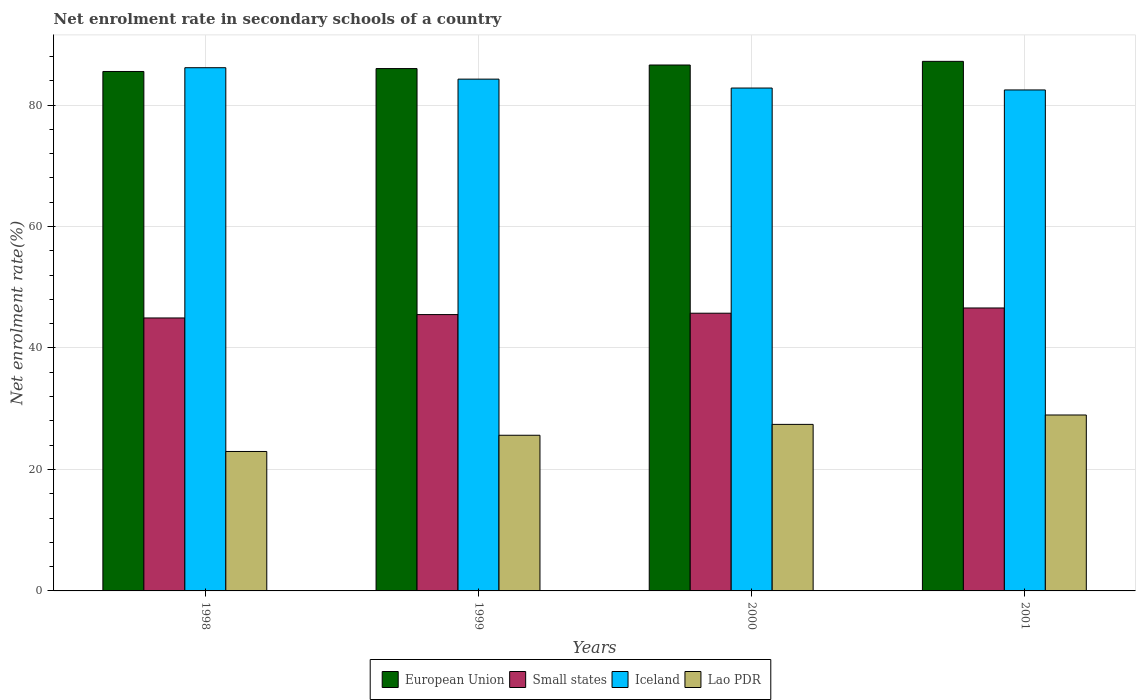How many groups of bars are there?
Provide a succinct answer. 4. Are the number of bars per tick equal to the number of legend labels?
Your answer should be compact. Yes. Are the number of bars on each tick of the X-axis equal?
Keep it short and to the point. Yes. How many bars are there on the 4th tick from the left?
Your answer should be compact. 4. How many bars are there on the 4th tick from the right?
Give a very brief answer. 4. What is the net enrolment rate in secondary schools in Small states in 1998?
Offer a terse response. 44.94. Across all years, what is the maximum net enrolment rate in secondary schools in Lao PDR?
Give a very brief answer. 28.97. Across all years, what is the minimum net enrolment rate in secondary schools in Small states?
Your answer should be very brief. 44.94. In which year was the net enrolment rate in secondary schools in European Union maximum?
Your response must be concise. 2001. In which year was the net enrolment rate in secondary schools in Iceland minimum?
Offer a very short reply. 2001. What is the total net enrolment rate in secondary schools in Lao PDR in the graph?
Make the answer very short. 104.98. What is the difference between the net enrolment rate in secondary schools in Iceland in 1999 and that in 2001?
Your answer should be compact. 1.78. What is the difference between the net enrolment rate in secondary schools in Iceland in 2000 and the net enrolment rate in secondary schools in Small states in 1998?
Your answer should be very brief. 37.86. What is the average net enrolment rate in secondary schools in European Union per year?
Offer a terse response. 86.33. In the year 2001, what is the difference between the net enrolment rate in secondary schools in Iceland and net enrolment rate in secondary schools in Small states?
Keep it short and to the point. 35.9. What is the ratio of the net enrolment rate in secondary schools in European Union in 1998 to that in 2001?
Your answer should be compact. 0.98. Is the net enrolment rate in secondary schools in Small states in 2000 less than that in 2001?
Offer a terse response. Yes. What is the difference between the highest and the second highest net enrolment rate in secondary schools in European Union?
Ensure brevity in your answer.  0.6. What is the difference between the highest and the lowest net enrolment rate in secondary schools in Lao PDR?
Give a very brief answer. 6.01. In how many years, is the net enrolment rate in secondary schools in European Union greater than the average net enrolment rate in secondary schools in European Union taken over all years?
Provide a succinct answer. 2. Is the sum of the net enrolment rate in secondary schools in European Union in 1998 and 2000 greater than the maximum net enrolment rate in secondary schools in Lao PDR across all years?
Your answer should be compact. Yes. Is it the case that in every year, the sum of the net enrolment rate in secondary schools in European Union and net enrolment rate in secondary schools in Lao PDR is greater than the sum of net enrolment rate in secondary schools in Small states and net enrolment rate in secondary schools in Iceland?
Your answer should be compact. Yes. What does the 4th bar from the left in 2000 represents?
Your response must be concise. Lao PDR. What does the 3rd bar from the right in 1999 represents?
Provide a succinct answer. Small states. Is it the case that in every year, the sum of the net enrolment rate in secondary schools in Lao PDR and net enrolment rate in secondary schools in Iceland is greater than the net enrolment rate in secondary schools in Small states?
Offer a terse response. Yes. How many bars are there?
Provide a succinct answer. 16. Are all the bars in the graph horizontal?
Offer a terse response. No. How many years are there in the graph?
Your response must be concise. 4. Does the graph contain grids?
Offer a very short reply. Yes. Where does the legend appear in the graph?
Ensure brevity in your answer.  Bottom center. How many legend labels are there?
Ensure brevity in your answer.  4. How are the legend labels stacked?
Provide a succinct answer. Horizontal. What is the title of the graph?
Provide a succinct answer. Net enrolment rate in secondary schools of a country. What is the label or title of the X-axis?
Offer a very short reply. Years. What is the label or title of the Y-axis?
Make the answer very short. Net enrolment rate(%). What is the Net enrolment rate(%) of European Union in 1998?
Keep it short and to the point. 85.53. What is the Net enrolment rate(%) in Small states in 1998?
Your answer should be very brief. 44.94. What is the Net enrolment rate(%) of Iceland in 1998?
Make the answer very short. 86.15. What is the Net enrolment rate(%) in Lao PDR in 1998?
Your answer should be very brief. 22.96. What is the Net enrolment rate(%) of European Union in 1999?
Keep it short and to the point. 86.01. What is the Net enrolment rate(%) in Small states in 1999?
Keep it short and to the point. 45.5. What is the Net enrolment rate(%) in Iceland in 1999?
Keep it short and to the point. 84.27. What is the Net enrolment rate(%) in Lao PDR in 1999?
Offer a very short reply. 25.63. What is the Net enrolment rate(%) in European Union in 2000?
Offer a very short reply. 86.59. What is the Net enrolment rate(%) in Small states in 2000?
Provide a short and direct response. 45.72. What is the Net enrolment rate(%) of Iceland in 2000?
Ensure brevity in your answer.  82.8. What is the Net enrolment rate(%) in Lao PDR in 2000?
Give a very brief answer. 27.42. What is the Net enrolment rate(%) in European Union in 2001?
Give a very brief answer. 87.19. What is the Net enrolment rate(%) of Small states in 2001?
Provide a short and direct response. 46.59. What is the Net enrolment rate(%) of Iceland in 2001?
Make the answer very short. 82.49. What is the Net enrolment rate(%) in Lao PDR in 2001?
Make the answer very short. 28.97. Across all years, what is the maximum Net enrolment rate(%) of European Union?
Your answer should be compact. 87.19. Across all years, what is the maximum Net enrolment rate(%) of Small states?
Provide a short and direct response. 46.59. Across all years, what is the maximum Net enrolment rate(%) of Iceland?
Make the answer very short. 86.15. Across all years, what is the maximum Net enrolment rate(%) in Lao PDR?
Your response must be concise. 28.97. Across all years, what is the minimum Net enrolment rate(%) of European Union?
Your response must be concise. 85.53. Across all years, what is the minimum Net enrolment rate(%) of Small states?
Ensure brevity in your answer.  44.94. Across all years, what is the minimum Net enrolment rate(%) in Iceland?
Keep it short and to the point. 82.49. Across all years, what is the minimum Net enrolment rate(%) in Lao PDR?
Give a very brief answer. 22.96. What is the total Net enrolment rate(%) in European Union in the graph?
Provide a succinct answer. 345.32. What is the total Net enrolment rate(%) in Small states in the graph?
Ensure brevity in your answer.  182.75. What is the total Net enrolment rate(%) of Iceland in the graph?
Offer a terse response. 335.7. What is the total Net enrolment rate(%) of Lao PDR in the graph?
Your answer should be very brief. 104.98. What is the difference between the Net enrolment rate(%) in European Union in 1998 and that in 1999?
Provide a succinct answer. -0.48. What is the difference between the Net enrolment rate(%) of Small states in 1998 and that in 1999?
Your response must be concise. -0.56. What is the difference between the Net enrolment rate(%) of Iceland in 1998 and that in 1999?
Your answer should be compact. 1.88. What is the difference between the Net enrolment rate(%) in Lao PDR in 1998 and that in 1999?
Provide a succinct answer. -2.67. What is the difference between the Net enrolment rate(%) of European Union in 1998 and that in 2000?
Your answer should be compact. -1.07. What is the difference between the Net enrolment rate(%) in Small states in 1998 and that in 2000?
Make the answer very short. -0.78. What is the difference between the Net enrolment rate(%) in Iceland in 1998 and that in 2000?
Provide a short and direct response. 3.35. What is the difference between the Net enrolment rate(%) in Lao PDR in 1998 and that in 2000?
Ensure brevity in your answer.  -4.46. What is the difference between the Net enrolment rate(%) in European Union in 1998 and that in 2001?
Make the answer very short. -1.67. What is the difference between the Net enrolment rate(%) of Small states in 1998 and that in 2001?
Your answer should be very brief. -1.64. What is the difference between the Net enrolment rate(%) in Iceland in 1998 and that in 2001?
Ensure brevity in your answer.  3.66. What is the difference between the Net enrolment rate(%) of Lao PDR in 1998 and that in 2001?
Give a very brief answer. -6.01. What is the difference between the Net enrolment rate(%) in European Union in 1999 and that in 2000?
Your answer should be very brief. -0.59. What is the difference between the Net enrolment rate(%) of Small states in 1999 and that in 2000?
Your answer should be compact. -0.22. What is the difference between the Net enrolment rate(%) of Iceland in 1999 and that in 2000?
Make the answer very short. 1.47. What is the difference between the Net enrolment rate(%) in Lao PDR in 1999 and that in 2000?
Offer a terse response. -1.79. What is the difference between the Net enrolment rate(%) of European Union in 1999 and that in 2001?
Offer a terse response. -1.19. What is the difference between the Net enrolment rate(%) in Small states in 1999 and that in 2001?
Provide a succinct answer. -1.09. What is the difference between the Net enrolment rate(%) of Iceland in 1999 and that in 2001?
Ensure brevity in your answer.  1.78. What is the difference between the Net enrolment rate(%) of Lao PDR in 1999 and that in 2001?
Make the answer very short. -3.34. What is the difference between the Net enrolment rate(%) in European Union in 2000 and that in 2001?
Make the answer very short. -0.6. What is the difference between the Net enrolment rate(%) in Small states in 2000 and that in 2001?
Your answer should be compact. -0.86. What is the difference between the Net enrolment rate(%) of Iceland in 2000 and that in 2001?
Your answer should be very brief. 0.31. What is the difference between the Net enrolment rate(%) of Lao PDR in 2000 and that in 2001?
Provide a short and direct response. -1.55. What is the difference between the Net enrolment rate(%) of European Union in 1998 and the Net enrolment rate(%) of Small states in 1999?
Keep it short and to the point. 40.03. What is the difference between the Net enrolment rate(%) of European Union in 1998 and the Net enrolment rate(%) of Iceland in 1999?
Offer a very short reply. 1.26. What is the difference between the Net enrolment rate(%) in European Union in 1998 and the Net enrolment rate(%) in Lao PDR in 1999?
Give a very brief answer. 59.9. What is the difference between the Net enrolment rate(%) in Small states in 1998 and the Net enrolment rate(%) in Iceland in 1999?
Offer a terse response. -39.32. What is the difference between the Net enrolment rate(%) of Small states in 1998 and the Net enrolment rate(%) of Lao PDR in 1999?
Your answer should be very brief. 19.31. What is the difference between the Net enrolment rate(%) of Iceland in 1998 and the Net enrolment rate(%) of Lao PDR in 1999?
Make the answer very short. 60.51. What is the difference between the Net enrolment rate(%) of European Union in 1998 and the Net enrolment rate(%) of Small states in 2000?
Make the answer very short. 39.8. What is the difference between the Net enrolment rate(%) of European Union in 1998 and the Net enrolment rate(%) of Iceland in 2000?
Offer a very short reply. 2.73. What is the difference between the Net enrolment rate(%) in European Union in 1998 and the Net enrolment rate(%) in Lao PDR in 2000?
Your answer should be very brief. 58.11. What is the difference between the Net enrolment rate(%) in Small states in 1998 and the Net enrolment rate(%) in Iceland in 2000?
Ensure brevity in your answer.  -37.86. What is the difference between the Net enrolment rate(%) of Small states in 1998 and the Net enrolment rate(%) of Lao PDR in 2000?
Offer a terse response. 17.52. What is the difference between the Net enrolment rate(%) in Iceland in 1998 and the Net enrolment rate(%) in Lao PDR in 2000?
Give a very brief answer. 58.72. What is the difference between the Net enrolment rate(%) in European Union in 1998 and the Net enrolment rate(%) in Small states in 2001?
Make the answer very short. 38.94. What is the difference between the Net enrolment rate(%) of European Union in 1998 and the Net enrolment rate(%) of Iceland in 2001?
Offer a terse response. 3.04. What is the difference between the Net enrolment rate(%) in European Union in 1998 and the Net enrolment rate(%) in Lao PDR in 2001?
Give a very brief answer. 56.56. What is the difference between the Net enrolment rate(%) in Small states in 1998 and the Net enrolment rate(%) in Iceland in 2001?
Provide a short and direct response. -37.54. What is the difference between the Net enrolment rate(%) in Small states in 1998 and the Net enrolment rate(%) in Lao PDR in 2001?
Your response must be concise. 15.97. What is the difference between the Net enrolment rate(%) of Iceland in 1998 and the Net enrolment rate(%) of Lao PDR in 2001?
Provide a short and direct response. 57.18. What is the difference between the Net enrolment rate(%) in European Union in 1999 and the Net enrolment rate(%) in Small states in 2000?
Your answer should be very brief. 40.28. What is the difference between the Net enrolment rate(%) of European Union in 1999 and the Net enrolment rate(%) of Iceland in 2000?
Ensure brevity in your answer.  3.21. What is the difference between the Net enrolment rate(%) in European Union in 1999 and the Net enrolment rate(%) in Lao PDR in 2000?
Your response must be concise. 58.59. What is the difference between the Net enrolment rate(%) of Small states in 1999 and the Net enrolment rate(%) of Iceland in 2000?
Provide a succinct answer. -37.3. What is the difference between the Net enrolment rate(%) in Small states in 1999 and the Net enrolment rate(%) in Lao PDR in 2000?
Make the answer very short. 18.08. What is the difference between the Net enrolment rate(%) in Iceland in 1999 and the Net enrolment rate(%) in Lao PDR in 2000?
Provide a short and direct response. 56.85. What is the difference between the Net enrolment rate(%) in European Union in 1999 and the Net enrolment rate(%) in Small states in 2001?
Make the answer very short. 39.42. What is the difference between the Net enrolment rate(%) in European Union in 1999 and the Net enrolment rate(%) in Iceland in 2001?
Your response must be concise. 3.52. What is the difference between the Net enrolment rate(%) in European Union in 1999 and the Net enrolment rate(%) in Lao PDR in 2001?
Keep it short and to the point. 57.04. What is the difference between the Net enrolment rate(%) in Small states in 1999 and the Net enrolment rate(%) in Iceland in 2001?
Give a very brief answer. -36.99. What is the difference between the Net enrolment rate(%) in Small states in 1999 and the Net enrolment rate(%) in Lao PDR in 2001?
Offer a terse response. 16.53. What is the difference between the Net enrolment rate(%) of Iceland in 1999 and the Net enrolment rate(%) of Lao PDR in 2001?
Provide a short and direct response. 55.3. What is the difference between the Net enrolment rate(%) of European Union in 2000 and the Net enrolment rate(%) of Small states in 2001?
Provide a short and direct response. 40.01. What is the difference between the Net enrolment rate(%) of European Union in 2000 and the Net enrolment rate(%) of Iceland in 2001?
Provide a short and direct response. 4.11. What is the difference between the Net enrolment rate(%) in European Union in 2000 and the Net enrolment rate(%) in Lao PDR in 2001?
Provide a succinct answer. 57.63. What is the difference between the Net enrolment rate(%) in Small states in 2000 and the Net enrolment rate(%) in Iceland in 2001?
Make the answer very short. -36.76. What is the difference between the Net enrolment rate(%) in Small states in 2000 and the Net enrolment rate(%) in Lao PDR in 2001?
Offer a very short reply. 16.76. What is the difference between the Net enrolment rate(%) in Iceland in 2000 and the Net enrolment rate(%) in Lao PDR in 2001?
Offer a very short reply. 53.83. What is the average Net enrolment rate(%) in European Union per year?
Offer a terse response. 86.33. What is the average Net enrolment rate(%) in Small states per year?
Provide a succinct answer. 45.69. What is the average Net enrolment rate(%) in Iceland per year?
Your response must be concise. 83.92. What is the average Net enrolment rate(%) of Lao PDR per year?
Make the answer very short. 26.25. In the year 1998, what is the difference between the Net enrolment rate(%) of European Union and Net enrolment rate(%) of Small states?
Make the answer very short. 40.58. In the year 1998, what is the difference between the Net enrolment rate(%) in European Union and Net enrolment rate(%) in Iceland?
Offer a terse response. -0.62. In the year 1998, what is the difference between the Net enrolment rate(%) of European Union and Net enrolment rate(%) of Lao PDR?
Provide a short and direct response. 62.57. In the year 1998, what is the difference between the Net enrolment rate(%) of Small states and Net enrolment rate(%) of Iceland?
Offer a terse response. -41.2. In the year 1998, what is the difference between the Net enrolment rate(%) in Small states and Net enrolment rate(%) in Lao PDR?
Provide a succinct answer. 21.98. In the year 1998, what is the difference between the Net enrolment rate(%) of Iceland and Net enrolment rate(%) of Lao PDR?
Your answer should be compact. 63.19. In the year 1999, what is the difference between the Net enrolment rate(%) in European Union and Net enrolment rate(%) in Small states?
Provide a succinct answer. 40.51. In the year 1999, what is the difference between the Net enrolment rate(%) in European Union and Net enrolment rate(%) in Iceland?
Keep it short and to the point. 1.74. In the year 1999, what is the difference between the Net enrolment rate(%) in European Union and Net enrolment rate(%) in Lao PDR?
Give a very brief answer. 60.38. In the year 1999, what is the difference between the Net enrolment rate(%) of Small states and Net enrolment rate(%) of Iceland?
Provide a short and direct response. -38.77. In the year 1999, what is the difference between the Net enrolment rate(%) in Small states and Net enrolment rate(%) in Lao PDR?
Give a very brief answer. 19.87. In the year 1999, what is the difference between the Net enrolment rate(%) of Iceland and Net enrolment rate(%) of Lao PDR?
Provide a succinct answer. 58.63. In the year 2000, what is the difference between the Net enrolment rate(%) in European Union and Net enrolment rate(%) in Small states?
Give a very brief answer. 40.87. In the year 2000, what is the difference between the Net enrolment rate(%) of European Union and Net enrolment rate(%) of Iceland?
Your answer should be compact. 3.79. In the year 2000, what is the difference between the Net enrolment rate(%) in European Union and Net enrolment rate(%) in Lao PDR?
Provide a succinct answer. 59.17. In the year 2000, what is the difference between the Net enrolment rate(%) in Small states and Net enrolment rate(%) in Iceland?
Offer a very short reply. -37.08. In the year 2000, what is the difference between the Net enrolment rate(%) in Small states and Net enrolment rate(%) in Lao PDR?
Offer a very short reply. 18.3. In the year 2000, what is the difference between the Net enrolment rate(%) of Iceland and Net enrolment rate(%) of Lao PDR?
Your answer should be very brief. 55.38. In the year 2001, what is the difference between the Net enrolment rate(%) in European Union and Net enrolment rate(%) in Small states?
Give a very brief answer. 40.61. In the year 2001, what is the difference between the Net enrolment rate(%) of European Union and Net enrolment rate(%) of Iceland?
Keep it short and to the point. 4.71. In the year 2001, what is the difference between the Net enrolment rate(%) of European Union and Net enrolment rate(%) of Lao PDR?
Provide a short and direct response. 58.23. In the year 2001, what is the difference between the Net enrolment rate(%) of Small states and Net enrolment rate(%) of Iceland?
Ensure brevity in your answer.  -35.9. In the year 2001, what is the difference between the Net enrolment rate(%) in Small states and Net enrolment rate(%) in Lao PDR?
Your answer should be very brief. 17.62. In the year 2001, what is the difference between the Net enrolment rate(%) of Iceland and Net enrolment rate(%) of Lao PDR?
Provide a short and direct response. 53.52. What is the ratio of the Net enrolment rate(%) in European Union in 1998 to that in 1999?
Your answer should be very brief. 0.99. What is the ratio of the Net enrolment rate(%) in Small states in 1998 to that in 1999?
Ensure brevity in your answer.  0.99. What is the ratio of the Net enrolment rate(%) in Iceland in 1998 to that in 1999?
Ensure brevity in your answer.  1.02. What is the ratio of the Net enrolment rate(%) of Lao PDR in 1998 to that in 1999?
Ensure brevity in your answer.  0.9. What is the ratio of the Net enrolment rate(%) of European Union in 1998 to that in 2000?
Your response must be concise. 0.99. What is the ratio of the Net enrolment rate(%) of Small states in 1998 to that in 2000?
Make the answer very short. 0.98. What is the ratio of the Net enrolment rate(%) in Iceland in 1998 to that in 2000?
Your answer should be compact. 1.04. What is the ratio of the Net enrolment rate(%) in Lao PDR in 1998 to that in 2000?
Your answer should be very brief. 0.84. What is the ratio of the Net enrolment rate(%) in European Union in 1998 to that in 2001?
Your answer should be very brief. 0.98. What is the ratio of the Net enrolment rate(%) in Small states in 1998 to that in 2001?
Provide a short and direct response. 0.96. What is the ratio of the Net enrolment rate(%) of Iceland in 1998 to that in 2001?
Offer a very short reply. 1.04. What is the ratio of the Net enrolment rate(%) in Lao PDR in 1998 to that in 2001?
Offer a terse response. 0.79. What is the ratio of the Net enrolment rate(%) in Iceland in 1999 to that in 2000?
Your response must be concise. 1.02. What is the ratio of the Net enrolment rate(%) of Lao PDR in 1999 to that in 2000?
Make the answer very short. 0.93. What is the ratio of the Net enrolment rate(%) of European Union in 1999 to that in 2001?
Ensure brevity in your answer.  0.99. What is the ratio of the Net enrolment rate(%) in Small states in 1999 to that in 2001?
Your answer should be compact. 0.98. What is the ratio of the Net enrolment rate(%) in Iceland in 1999 to that in 2001?
Your answer should be compact. 1.02. What is the ratio of the Net enrolment rate(%) in Lao PDR in 1999 to that in 2001?
Keep it short and to the point. 0.88. What is the ratio of the Net enrolment rate(%) in Small states in 2000 to that in 2001?
Offer a terse response. 0.98. What is the ratio of the Net enrolment rate(%) in Iceland in 2000 to that in 2001?
Offer a terse response. 1. What is the ratio of the Net enrolment rate(%) in Lao PDR in 2000 to that in 2001?
Your response must be concise. 0.95. What is the difference between the highest and the second highest Net enrolment rate(%) of European Union?
Provide a succinct answer. 0.6. What is the difference between the highest and the second highest Net enrolment rate(%) in Small states?
Keep it short and to the point. 0.86. What is the difference between the highest and the second highest Net enrolment rate(%) of Iceland?
Make the answer very short. 1.88. What is the difference between the highest and the second highest Net enrolment rate(%) of Lao PDR?
Provide a succinct answer. 1.55. What is the difference between the highest and the lowest Net enrolment rate(%) in European Union?
Offer a very short reply. 1.67. What is the difference between the highest and the lowest Net enrolment rate(%) of Small states?
Provide a succinct answer. 1.64. What is the difference between the highest and the lowest Net enrolment rate(%) of Iceland?
Make the answer very short. 3.66. What is the difference between the highest and the lowest Net enrolment rate(%) of Lao PDR?
Offer a terse response. 6.01. 